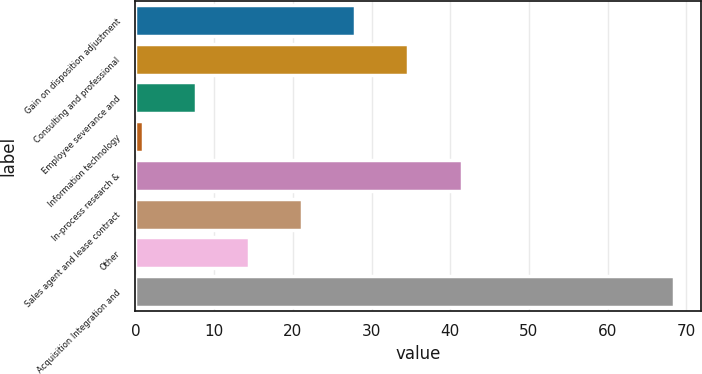Convert chart to OTSL. <chart><loc_0><loc_0><loc_500><loc_500><bar_chart><fcel>Gain on disposition adjustment<fcel>Consulting and professional<fcel>Employee severance and<fcel>Information technology<fcel>In-process research &<fcel>Sales agent and lease contract<fcel>Other<fcel>Acquisition Integration and<nl><fcel>27.94<fcel>34.7<fcel>7.66<fcel>0.9<fcel>41.46<fcel>21.18<fcel>14.42<fcel>68.5<nl></chart> 